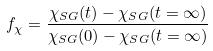Convert formula to latex. <formula><loc_0><loc_0><loc_500><loc_500>f _ { \chi } = \frac { \chi _ { S G } ( t ) - \chi _ { S G } ( t = \infty ) } { \chi _ { S G } ( 0 ) - \chi _ { S G } ( t = \infty ) }</formula> 